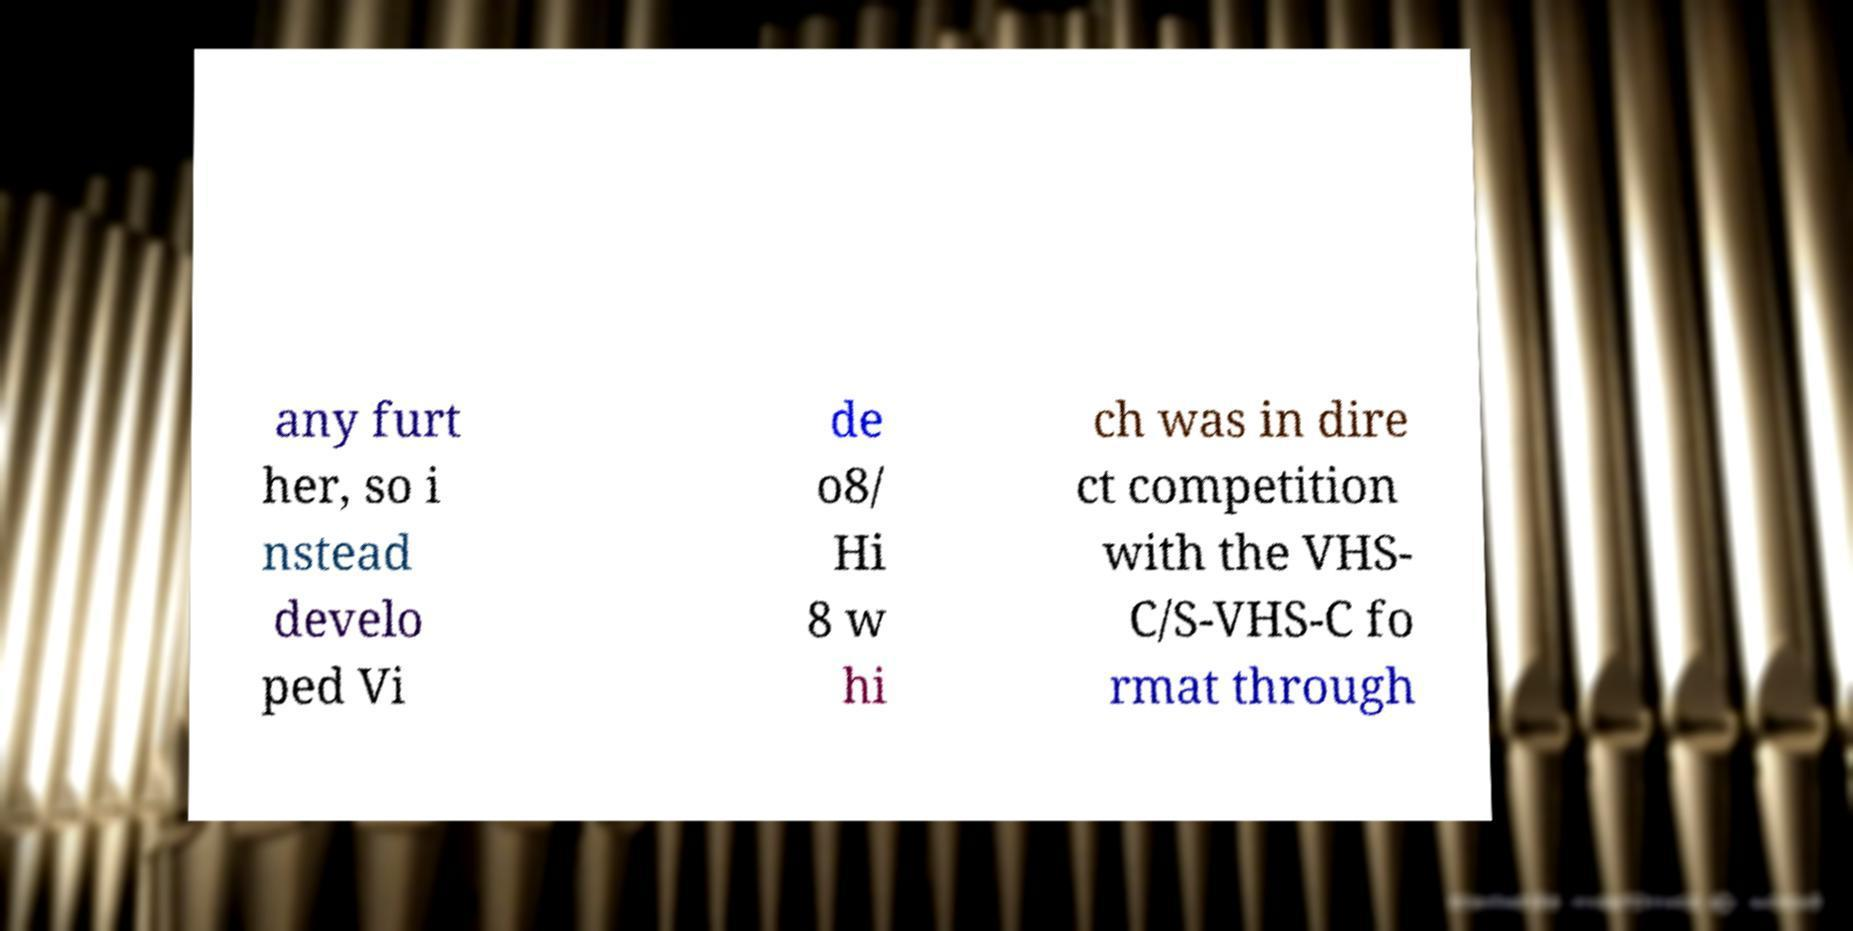There's text embedded in this image that I need extracted. Can you transcribe it verbatim? any furt her, so i nstead develo ped Vi de o8/ Hi 8 w hi ch was in dire ct competition with the VHS- C/S-VHS-C fo rmat through 